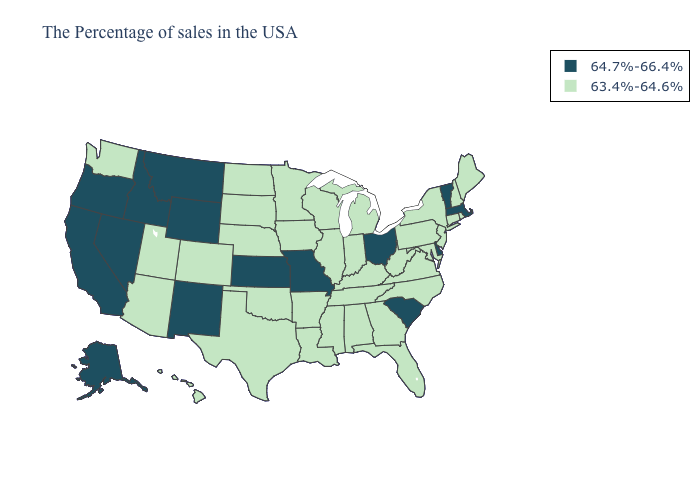Is the legend a continuous bar?
Answer briefly. No. Name the states that have a value in the range 63.4%-64.6%?
Keep it brief. Maine, Rhode Island, New Hampshire, Connecticut, New York, New Jersey, Maryland, Pennsylvania, Virginia, North Carolina, West Virginia, Florida, Georgia, Michigan, Kentucky, Indiana, Alabama, Tennessee, Wisconsin, Illinois, Mississippi, Louisiana, Arkansas, Minnesota, Iowa, Nebraska, Oklahoma, Texas, South Dakota, North Dakota, Colorado, Utah, Arizona, Washington, Hawaii. What is the value of Indiana?
Be succinct. 63.4%-64.6%. Name the states that have a value in the range 63.4%-64.6%?
Be succinct. Maine, Rhode Island, New Hampshire, Connecticut, New York, New Jersey, Maryland, Pennsylvania, Virginia, North Carolina, West Virginia, Florida, Georgia, Michigan, Kentucky, Indiana, Alabama, Tennessee, Wisconsin, Illinois, Mississippi, Louisiana, Arkansas, Minnesota, Iowa, Nebraska, Oklahoma, Texas, South Dakota, North Dakota, Colorado, Utah, Arizona, Washington, Hawaii. What is the lowest value in the Northeast?
Be succinct. 63.4%-64.6%. Does Connecticut have a lower value than Alaska?
Be succinct. Yes. What is the value of Arkansas?
Write a very short answer. 63.4%-64.6%. How many symbols are there in the legend?
Quick response, please. 2. Name the states that have a value in the range 64.7%-66.4%?
Short answer required. Massachusetts, Vermont, Delaware, South Carolina, Ohio, Missouri, Kansas, Wyoming, New Mexico, Montana, Idaho, Nevada, California, Oregon, Alaska. Does Connecticut have the same value as Massachusetts?
Quick response, please. No. Does the first symbol in the legend represent the smallest category?
Answer briefly. No. Name the states that have a value in the range 64.7%-66.4%?
Write a very short answer. Massachusetts, Vermont, Delaware, South Carolina, Ohio, Missouri, Kansas, Wyoming, New Mexico, Montana, Idaho, Nevada, California, Oregon, Alaska. Does Vermont have the lowest value in the Northeast?
Quick response, please. No. Is the legend a continuous bar?
Short answer required. No. 